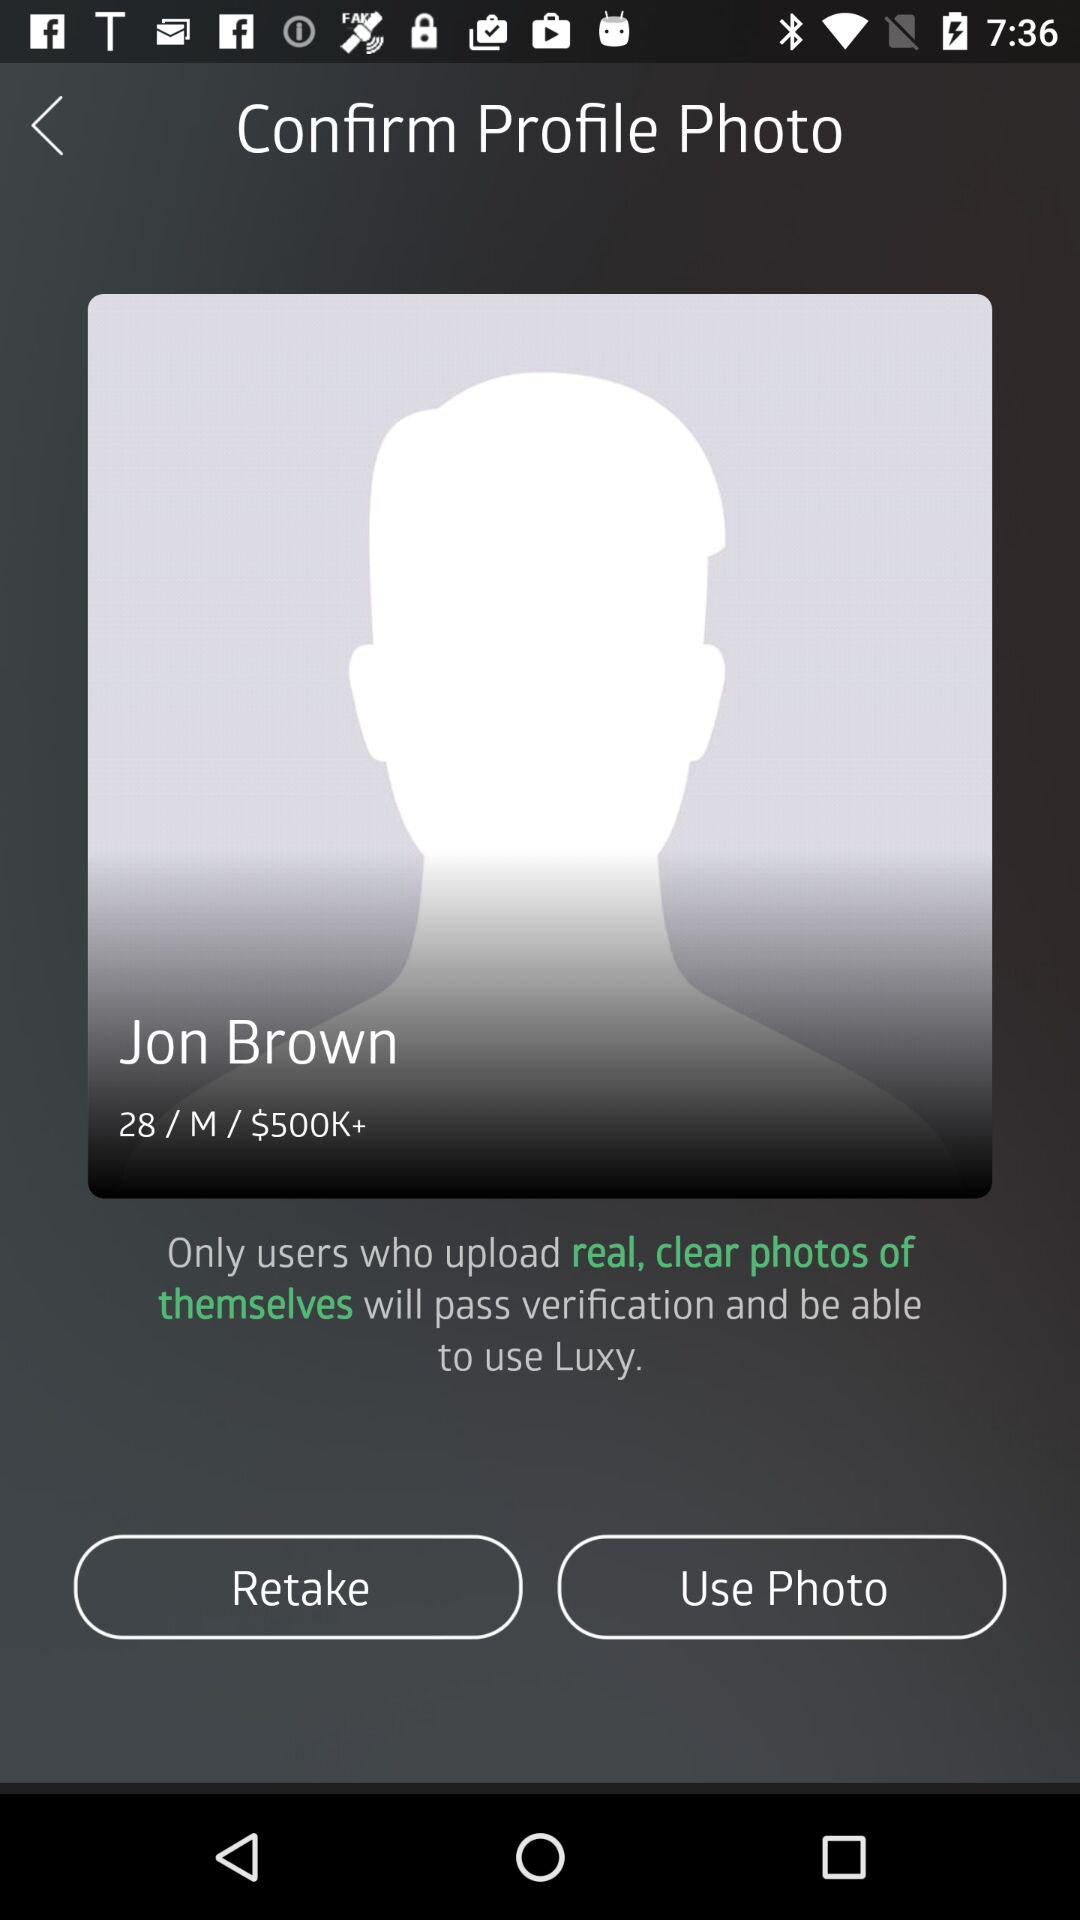What is the profile name? The profile name is Jon Brown. 